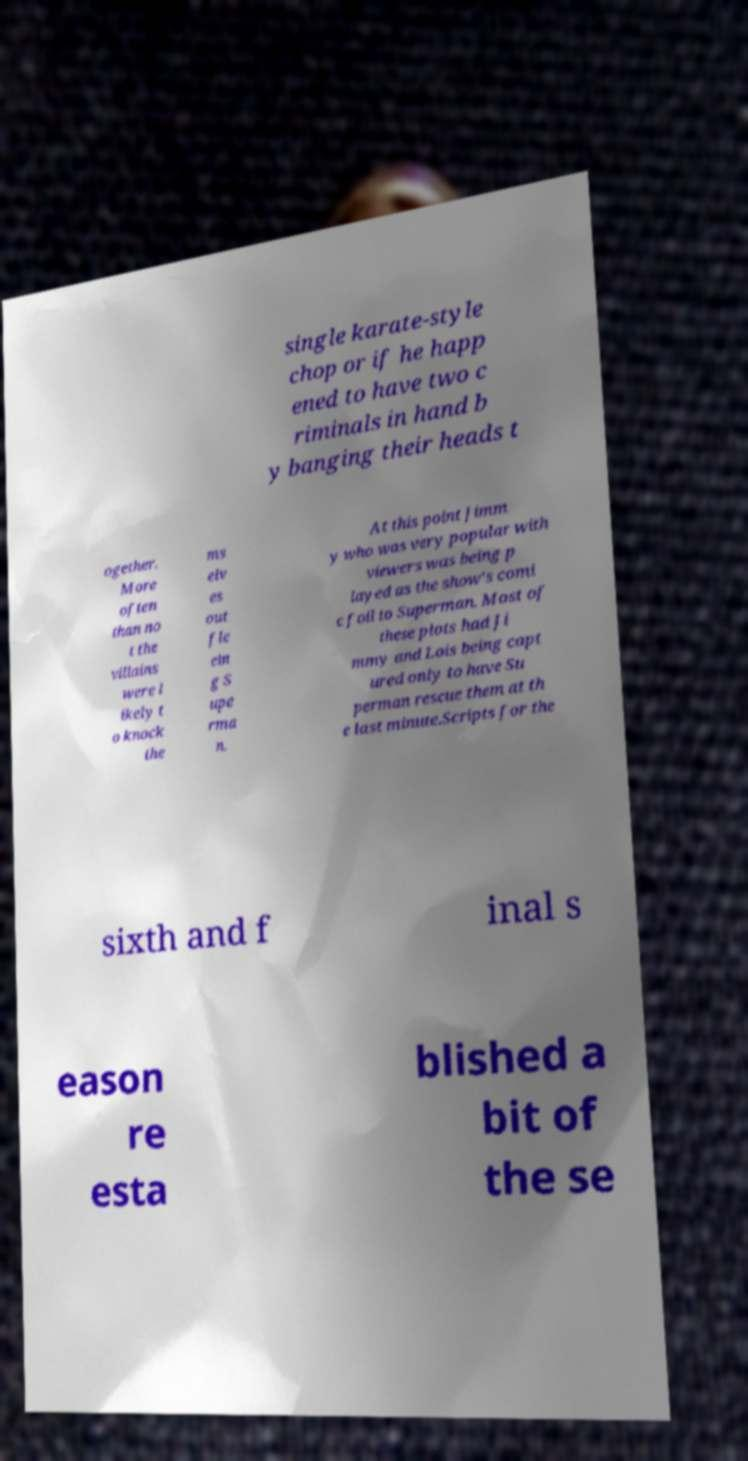I need the written content from this picture converted into text. Can you do that? single karate-style chop or if he happ ened to have two c riminals in hand b y banging their heads t ogether. More often than no t the villains were l ikely t o knock the ms elv es out fle ein g S upe rma n. At this point Jimm y who was very popular with viewers was being p layed as the show's comi c foil to Superman. Most of these plots had Ji mmy and Lois being capt ured only to have Su perman rescue them at th e last minute.Scripts for the sixth and f inal s eason re esta blished a bit of the se 